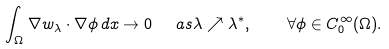Convert formula to latex. <formula><loc_0><loc_0><loc_500><loc_500>\int _ { \Omega } \nabla w _ { \lambda } \cdot \nabla \phi \, d x \to 0 \ \ a s \lambda \nearrow \lambda ^ { * } , \quad \forall \phi \in C ^ { \infty } _ { 0 } ( \Omega ) .</formula> 